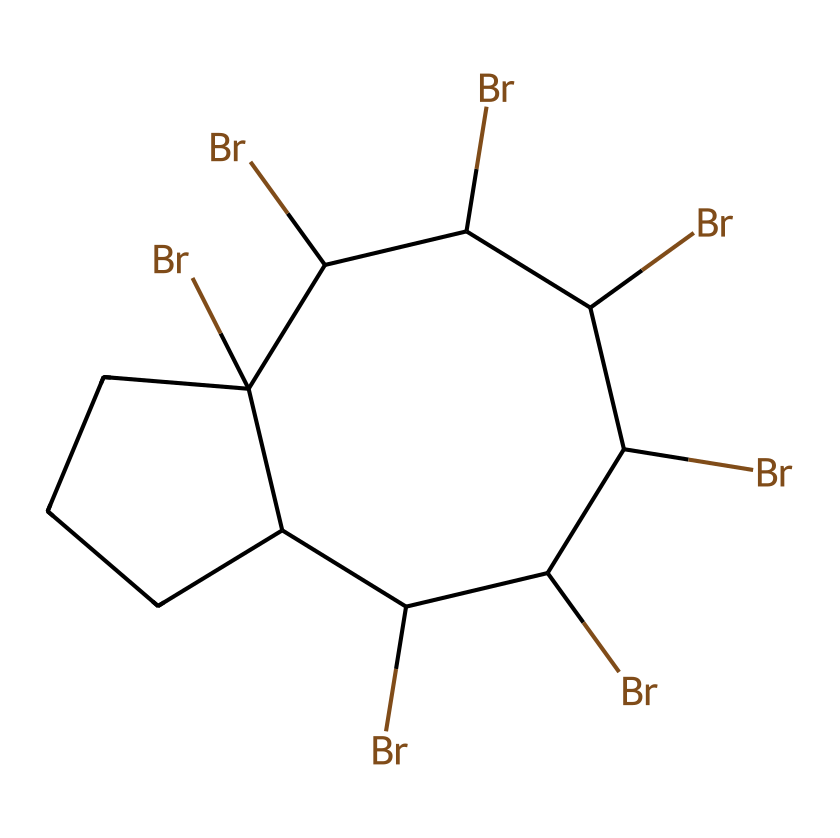What is the main element present in the SMILES representation? The SMILES representation indicates the presence of bromine atoms (Br) as a key element based on the notation used.
Answer: bromine How many bromine atoms are in the structure? By counting the occurrences of "Br" in the SMILES, there are six bromine atoms shown in the structure.
Answer: six What type of chemical compound is represented? The presence of multiple bromine atoms suggests that this structure is likely a brominated flame retardant, used to inhibit combustion.
Answer: flame retardant Does this chemical have any carbon atoms? The notation includes "C" multiple times, indicating the presence of carbon atoms in the structure.
Answer: yes What is the structural form of this compound based on the arrangement? The structure appears to be a cyclic compound due to the way carbon and bromine are interconnected.
Answer: cyclic How does the presence of bromine influence the flammability of this compound? Bromine is known to be a halogen, which typically acts as a fire retardant by inhibiting combustion reactions, making the compound less flammable.
Answer: reduces flammability What role do halogens play in flame retardants like this one? Halogens like bromine contribute to the flame-retarding properties by disrupting the combustion process, acting as good fire suppressants.
Answer: fire suppressants 